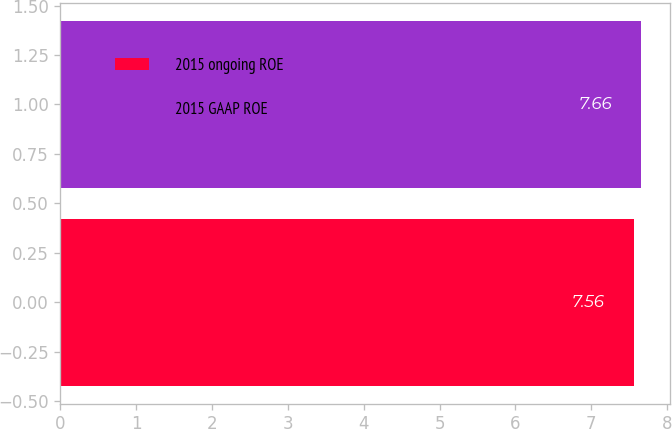Convert chart to OTSL. <chart><loc_0><loc_0><loc_500><loc_500><bar_chart><fcel>2015 ongoing ROE<fcel>2015 GAAP ROE<nl><fcel>7.56<fcel>7.66<nl></chart> 